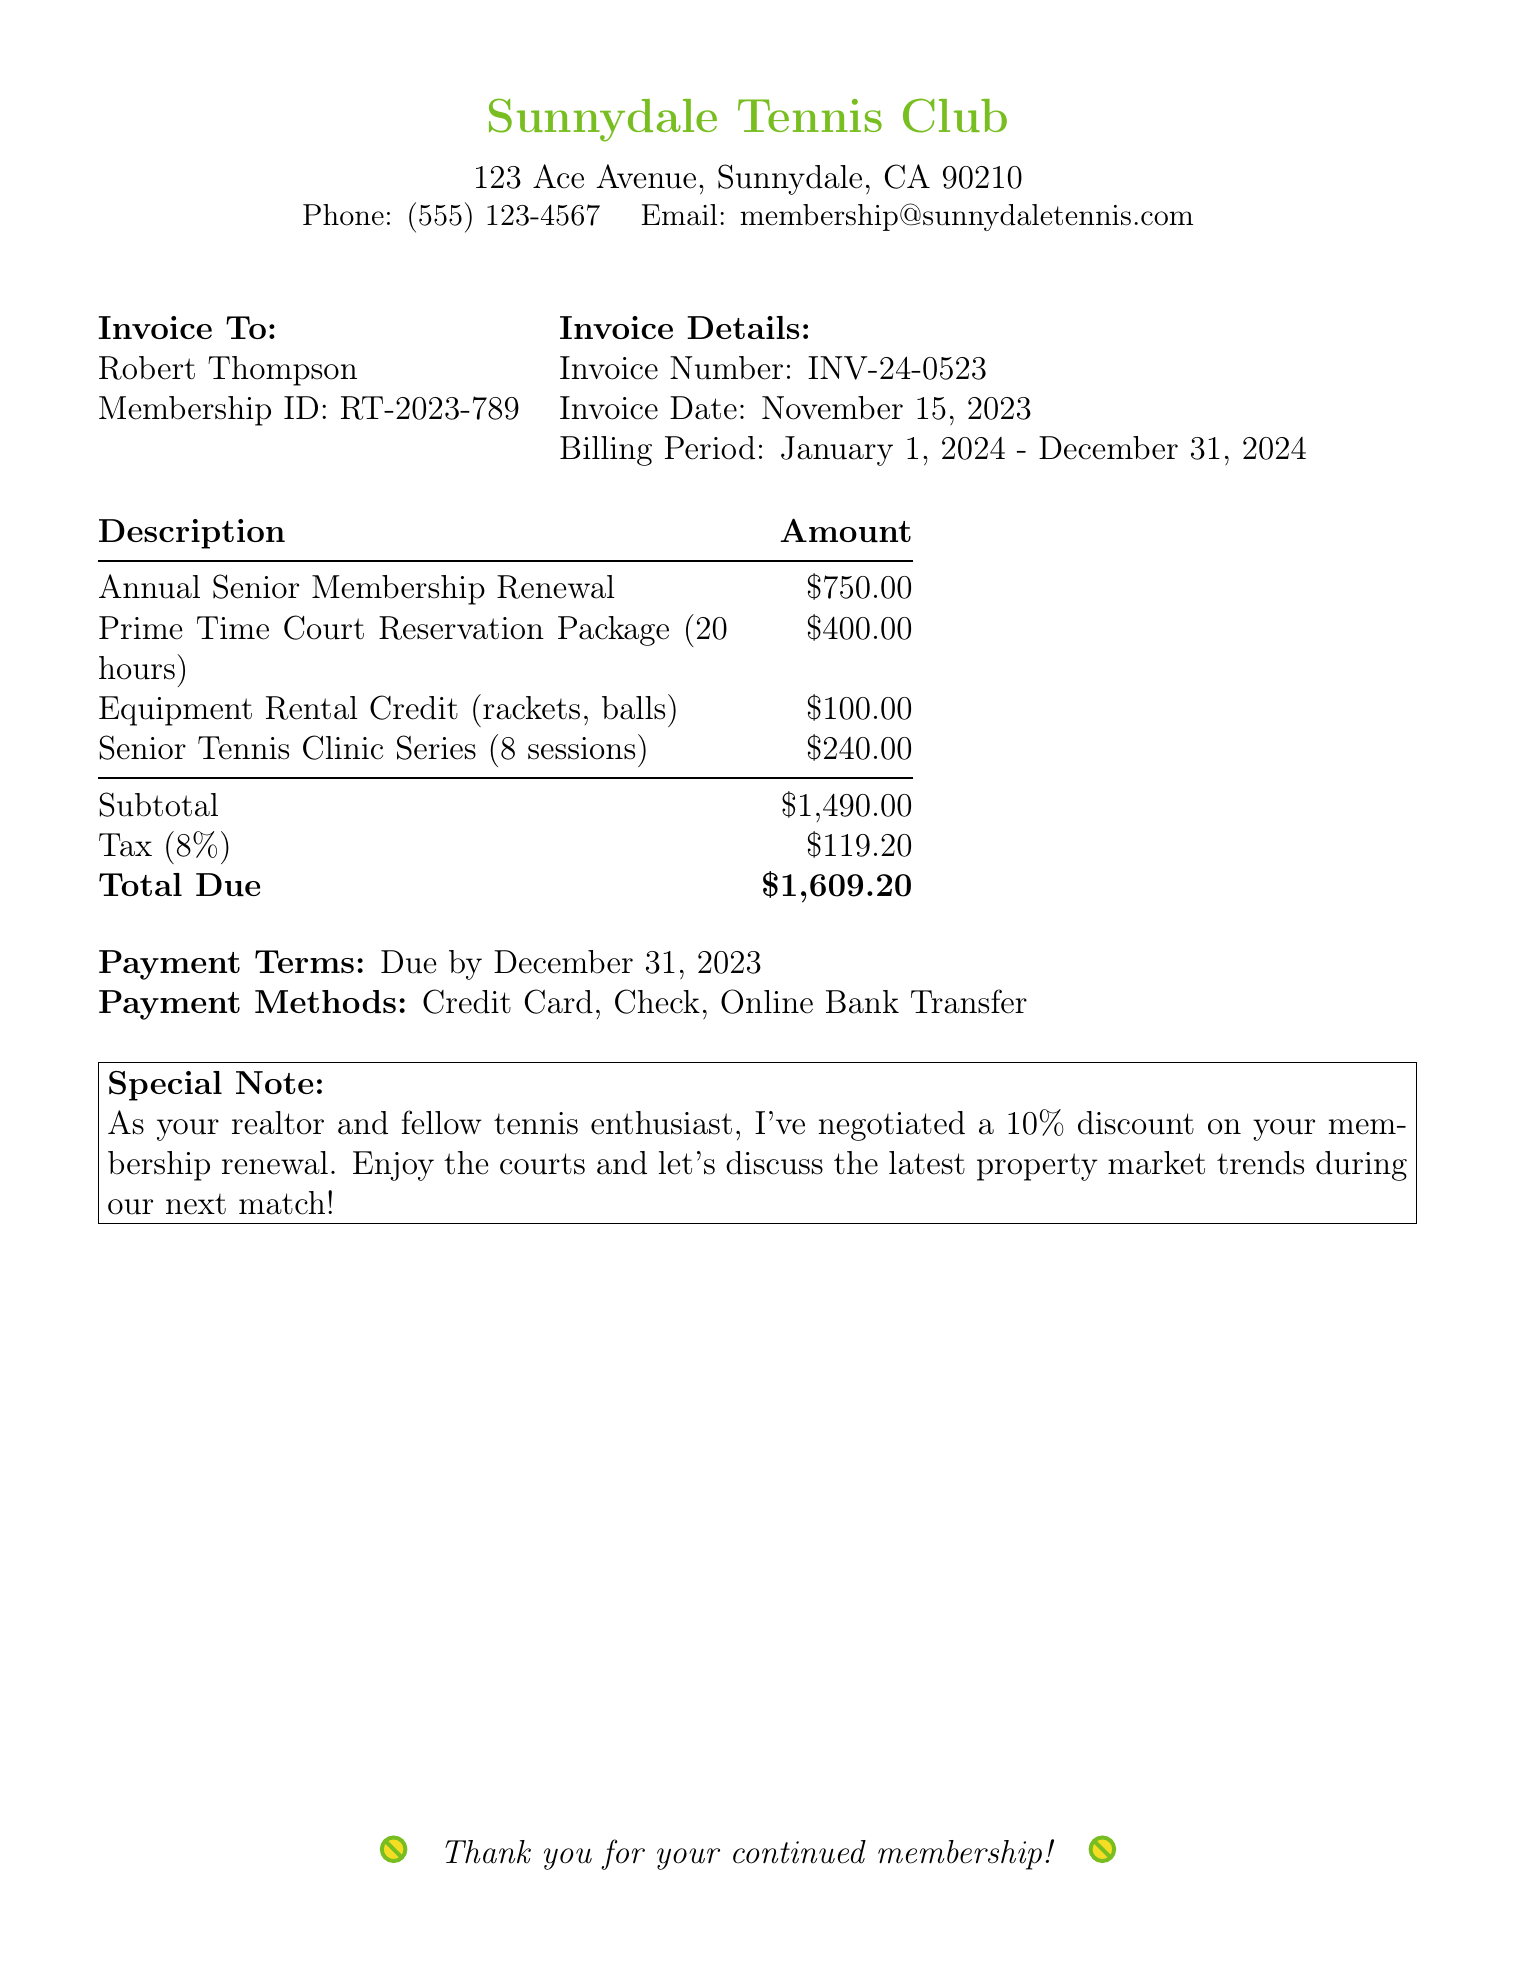What is the invoice number? The invoice number is located in the invoice details section of the document.
Answer: INV-24-0523 What is the annual membership renewal fee? The annual membership renewal fee is specified under the description section.
Answer: $750.00 What is the total amount due? The total amount due is the last entry in the amount table.
Answer: $1,609.20 When is the payment due? The due date for payment is mentioned towards the end of the document.
Answer: December 31, 2023 How many hours are included in the Prime Time Court Reservation Package? The number of hours is stated in the description of the package.
Answer: 20 hours What is the tax rate applied to the subtotal? The tax rate is specified in the subtotal and tax section.
Answer: 8% What special note is included for the member? The special note provides a personal message along with a discount.
Answer: 10% discount on your membership renewal How many sessions are included in the Senior Tennis Clinic Series? The number of sessions in the clinic series is listed in the description section.
Answer: 8 sessions What methods of payment are accepted? The accepted payment methods are detailed at the end of the document.
Answer: Credit Card, Check, Online Bank Transfer 